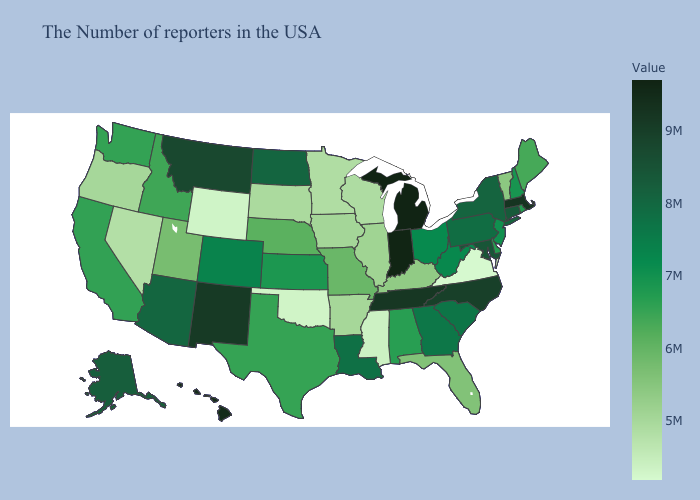Among the states that border Missouri , which have the lowest value?
Give a very brief answer. Oklahoma. Which states have the highest value in the USA?
Keep it brief. Michigan. Does North Dakota have a lower value than Oregon?
Keep it brief. No. Does Washington have the lowest value in the West?
Concise answer only. No. 